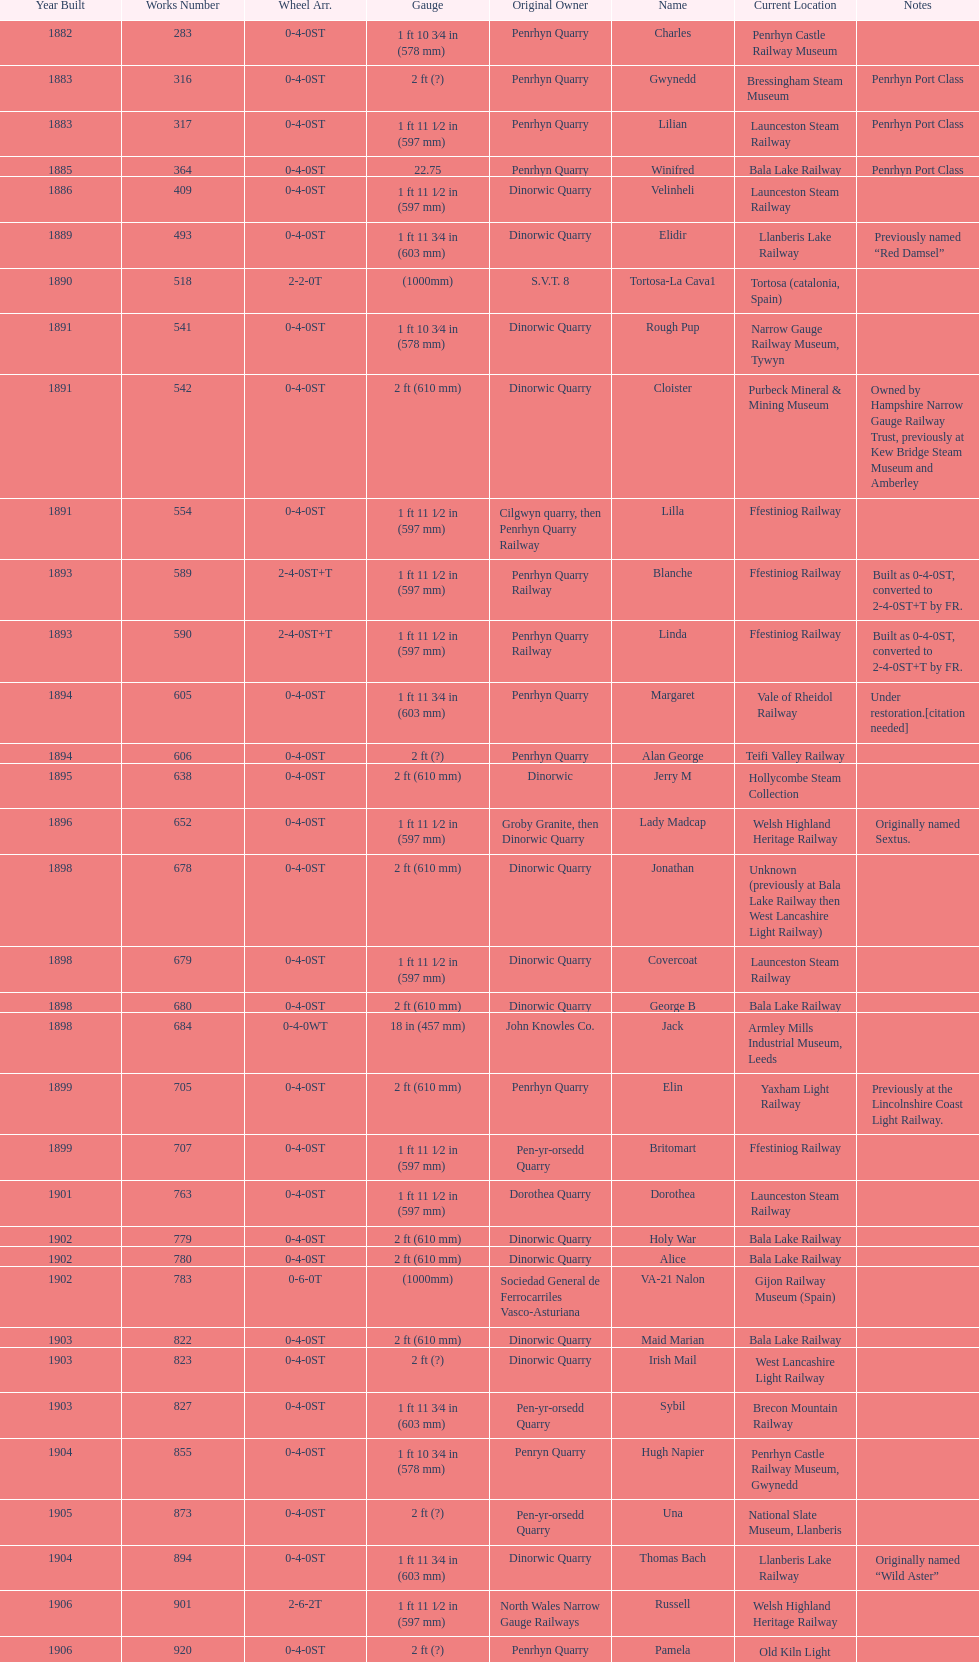In which year were the most steam locomotives built? 1898. 